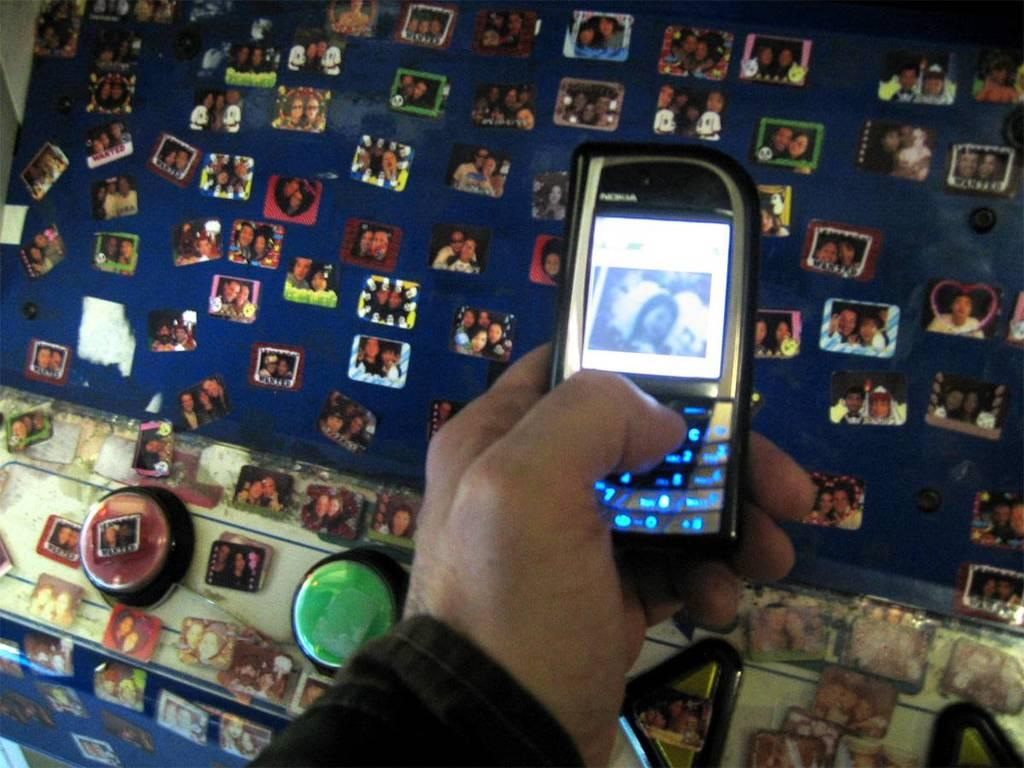Provide a one-sentence caption for the provided image. A nokia cellphone being held with a picture of  a girl displayed. 